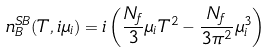<formula> <loc_0><loc_0><loc_500><loc_500>n _ { B } ^ { S B } ( T , i \mu _ { i } ) = i \left ( \frac { N _ { f } } { 3 } \mu _ { i } T ^ { 2 } - \frac { N _ { f } } { 3 \pi ^ { 2 } } \mu _ { i } ^ { 3 } \right )</formula> 